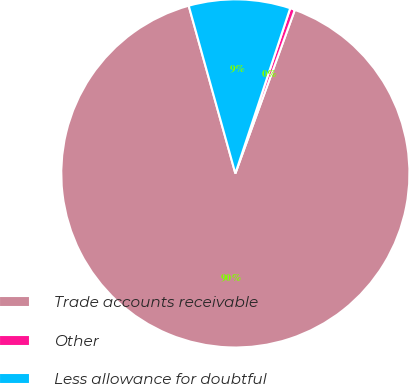<chart> <loc_0><loc_0><loc_500><loc_500><pie_chart><fcel>Trade accounts receivable<fcel>Other<fcel>Less allowance for doubtful<nl><fcel>90.13%<fcel>0.45%<fcel>9.42%<nl></chart> 